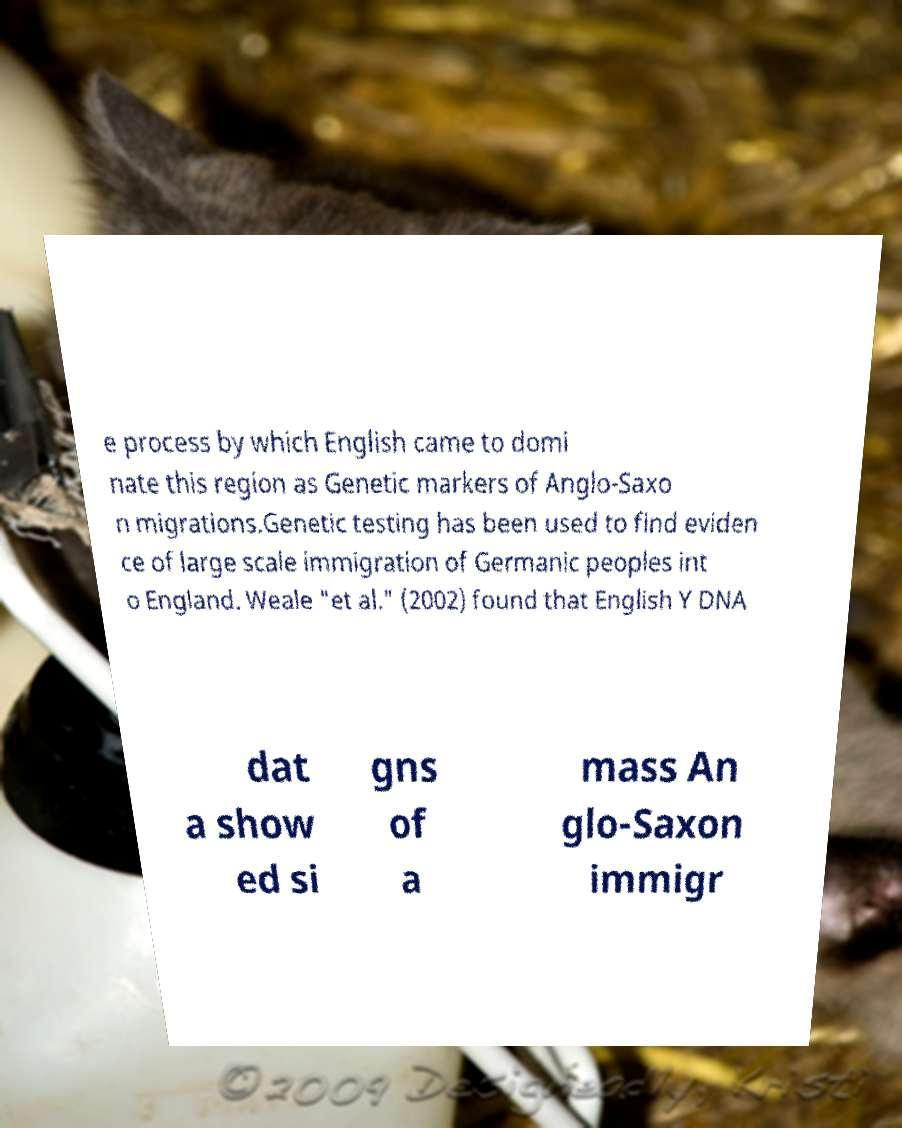Please read and relay the text visible in this image. What does it say? e process by which English came to domi nate this region as Genetic markers of Anglo-Saxo n migrations.Genetic testing has been used to find eviden ce of large scale immigration of Germanic peoples int o England. Weale "et al." (2002) found that English Y DNA dat a show ed si gns of a mass An glo-Saxon immigr 